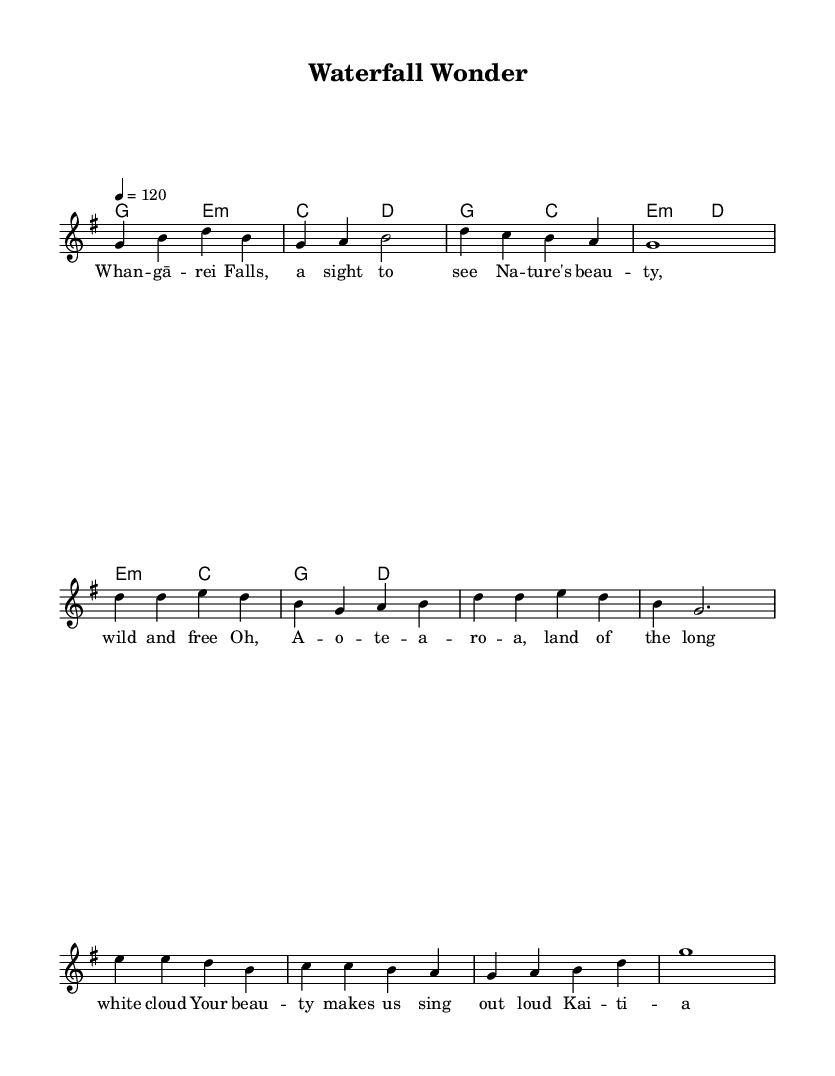What is the time signature of this music? The time signature is found at the beginning of the sheet music, indicated by the numbers stacked over each other. Here, it shows a 4 over 4, which means there are four beats in a measure.
Answer: 4/4 What is the tempo marking for this piece? The tempo marking is indicated in beats per minute and appears at the beginning of the score. In this case, it states "4 = 120," meaning that a quarter note gets 120 beats per minute.
Answer: 120 What is the key signature of this piece? The key signature is indicated at the beginning of the sheet music. Here, there is one sharp visible on the staff lines, indicating that the key is G major, which contains an F sharp.
Answer: G major How many measures are in the chorus section? To find the number of measures in the chorus section, you can count the individual measures grouped together in the chorus lyrics and associated melody. In this case, there are four measures in the chorus section.
Answer: 4 What is the primary theme of the lyrics? Examining the lyrics, the primary theme revolves around nature, as it speaks about the beauty of Whangārei Falls and the broader beauty of New Zealand. This reflects a deep appreciation for the natural landscape.
Answer: Nature's beauty What chord follows the second line of the verse? The chord progressions are indicated above the lyrics; the second line of the verse corresponds to the chord symbol 'e minor'. This can be observed right before the lyric "wild and free."
Answer: e minor How is the bridge musically different from the verse? The bridge section features a different sequence of notes and often presents a contrasting theme or mood in popular music. Here, it has new lyrics and distinct chord changes that differentiate it from the verse, giving it a unique character.
Answer: Different chord sequence 